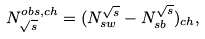<formula> <loc_0><loc_0><loc_500><loc_500>N ^ { o b s , c h } _ { \sqrt { s } } = ( N ^ { \sqrt { s } } _ { s w } - N ^ { \sqrt { s } } _ { s b } ) _ { c h } ,</formula> 